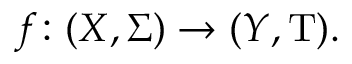Convert formula to latex. <formula><loc_0><loc_0><loc_500><loc_500>f \colon ( X , \Sigma ) \rightarrow ( Y , T ) .</formula> 